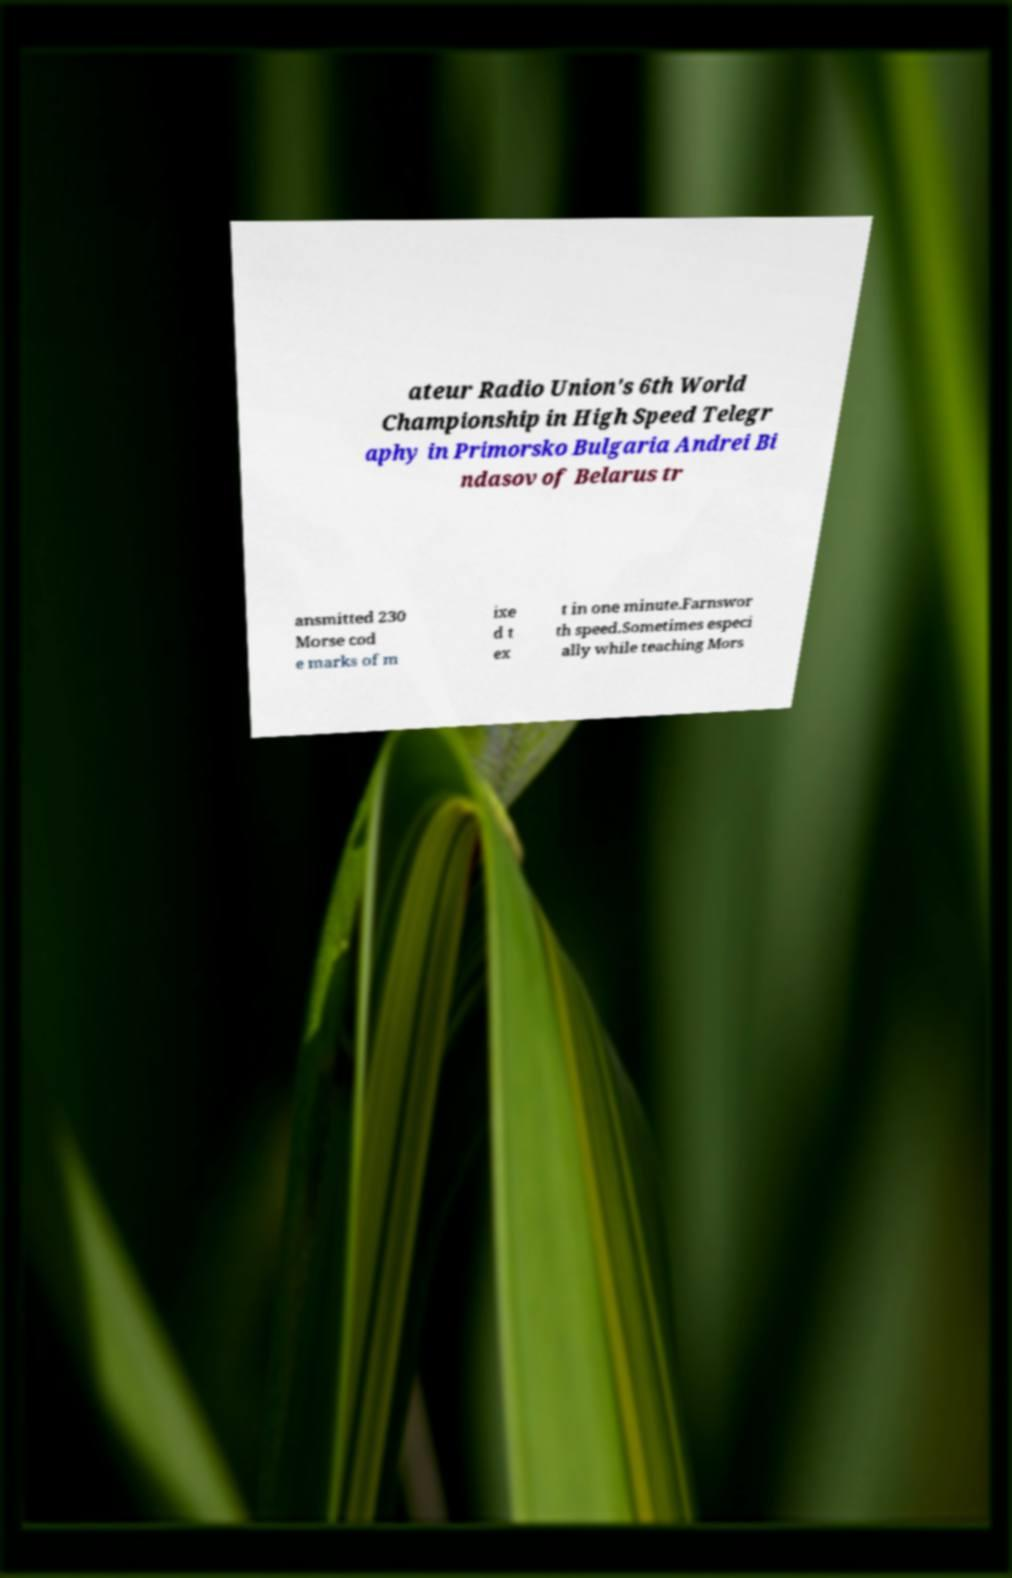Please identify and transcribe the text found in this image. ateur Radio Union's 6th World Championship in High Speed Telegr aphy in Primorsko Bulgaria Andrei Bi ndasov of Belarus tr ansmitted 230 Morse cod e marks of m ixe d t ex t in one minute.Farnswor th speed.Sometimes especi ally while teaching Mors 